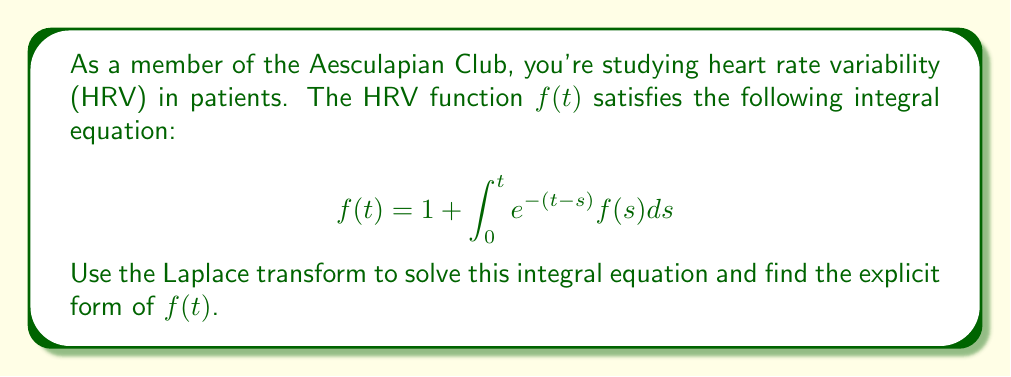Could you help me with this problem? Let's solve this step-by-step using the Laplace transform:

1) Let $F(s)$ be the Laplace transform of $f(t)$. Take the Laplace transform of both sides:

   $$\mathcal{L}\{f(t)\} = \mathcal{L}\{1\} + \mathcal{L}\{\int_0^t e^{-(t-s)}f(s)ds\}$$

2) Using Laplace transform properties:
   
   $$F(s) = \frac{1}{s} + \mathcal{L}\{e^{-t}\} \cdot F(s)$$

3) The Laplace transform of $e^{-t}$ is $\frac{1}{s+1}$, so:

   $$F(s) = \frac{1}{s} + \frac{1}{s+1}F(s)$$

4) Solve for $F(s)$:

   $$F(s) - \frac{1}{s+1}F(s) = \frac{1}{s}$$
   
   $$F(s)(\frac{s+1}{s+1} - \frac{1}{s+1}) = \frac{1}{s}$$
   
   $$F(s)(\frac{s}{s+1}) = \frac{1}{s}$$
   
   $$F(s) = \frac{s+1}{s^2}$$

5) Now we need to find the inverse Laplace transform of $F(s)$. We can split it into partial fractions:

   $$\frac{s+1}{s^2} = \frac{1}{s} + \frac{1}{s^2}$$

6) The inverse Laplace transform of $\frac{1}{s}$ is 1, and the inverse Laplace transform of $\frac{1}{s^2}$ is $t$. Therefore:

   $$f(t) = 1 + t$$

This is the explicit form of the HRV function $f(t)$.
Answer: $f(t) = 1 + t$ 